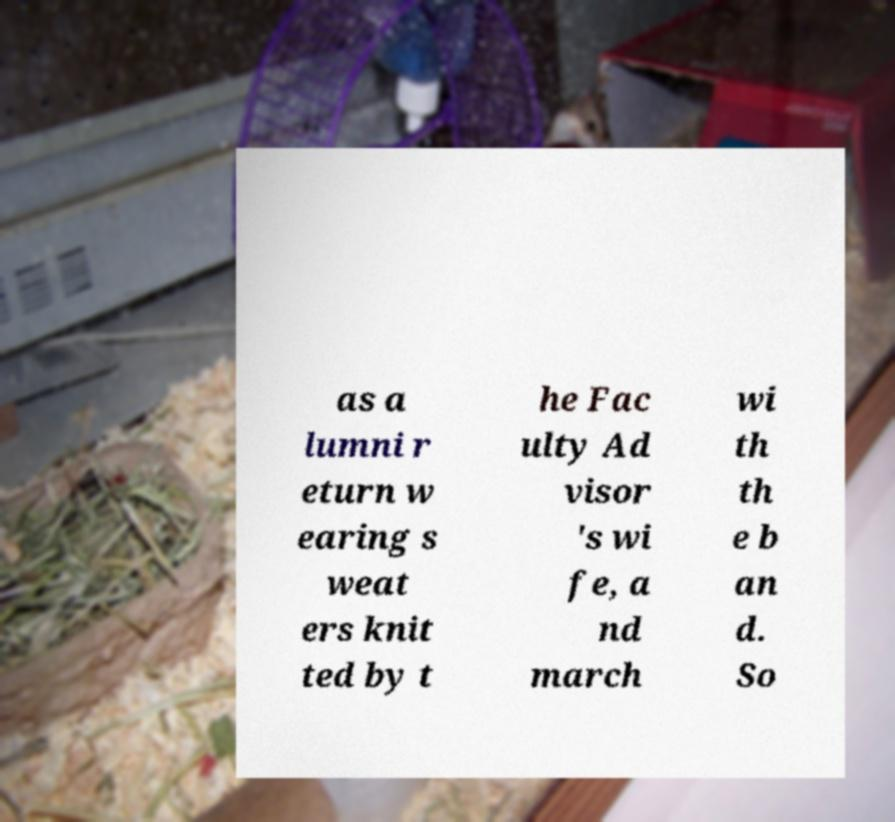Please read and relay the text visible in this image. What does it say? as a lumni r eturn w earing s weat ers knit ted by t he Fac ulty Ad visor 's wi fe, a nd march wi th th e b an d. So 